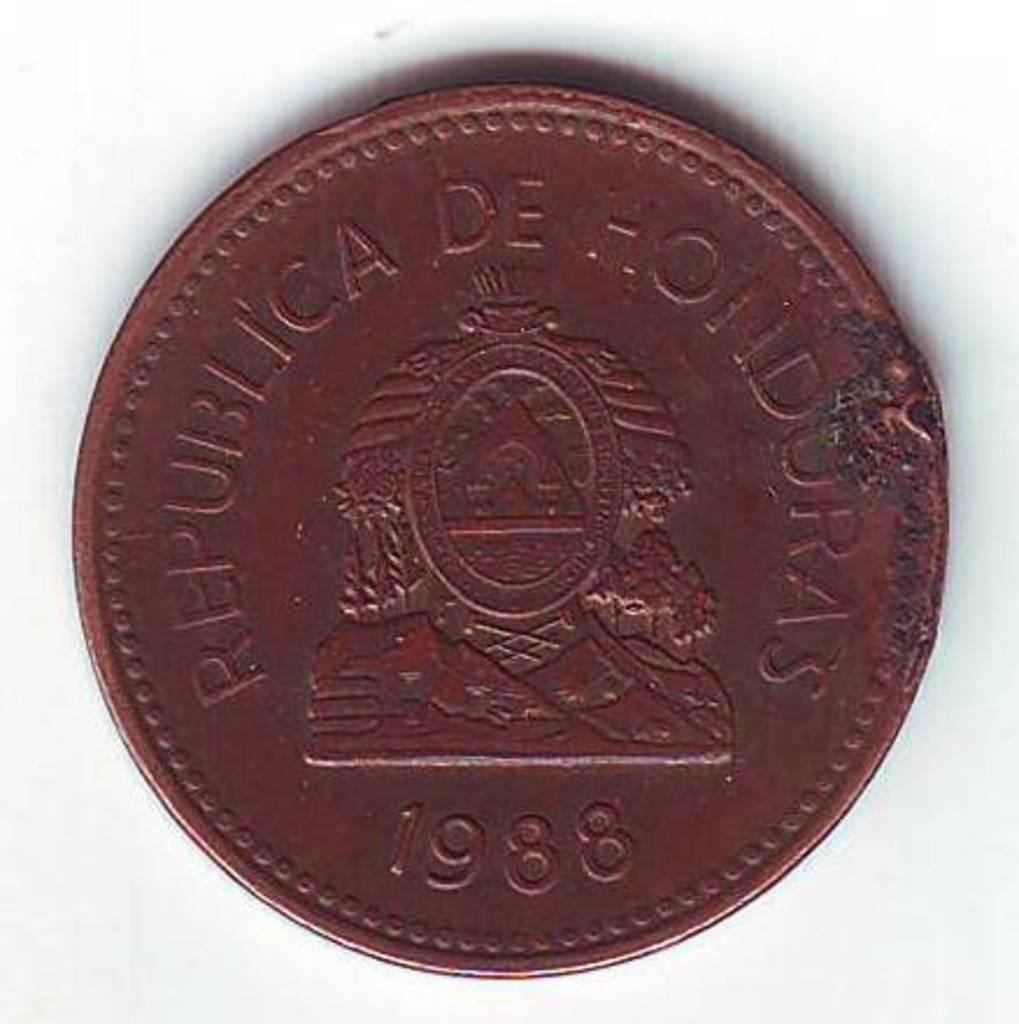What is the color of the surface in the image? The surface in the image is white colored. What object is placed on the surface? There is a coin on the surface. What can be observed about the color of the coin? The coin is brownish red in color. What information is printed on the coin? The year 1998 is printed on the coin, along with words and a symbol. How many passengers are visible in the image? There are no passengers present in the image; it features a coin on a white surface. What type of prose is written on the coin? There is no prose written on the coin; it has a symbol and printed words, including the year 1998. 